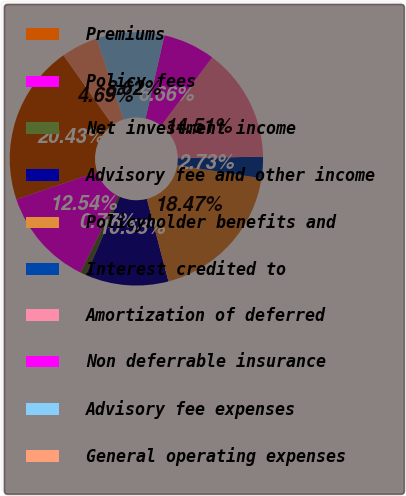<chart> <loc_0><loc_0><loc_500><loc_500><pie_chart><fcel>Premiums<fcel>Policy fees<fcel>Net investment income<fcel>Advisory fee and other income<fcel>Policyholder benefits and<fcel>Interest credited to<fcel>Amortization of deferred<fcel>Non deferrable insurance<fcel>Advisory fee expenses<fcel>General operating expenses<nl><fcel>20.43%<fcel>12.54%<fcel>0.77%<fcel>10.58%<fcel>18.47%<fcel>2.73%<fcel>14.51%<fcel>6.66%<fcel>8.62%<fcel>4.69%<nl></chart> 